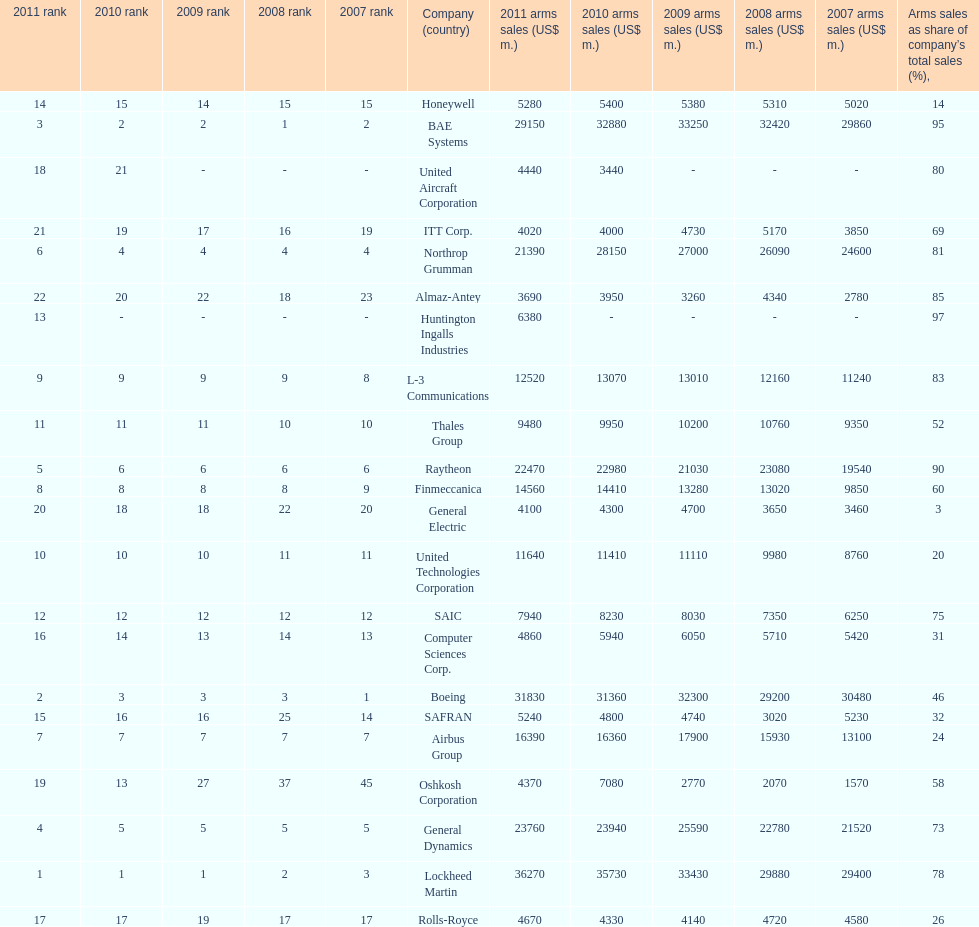Which is the only company to have under 10% arms sales as share of company's total sales? General Electric. 